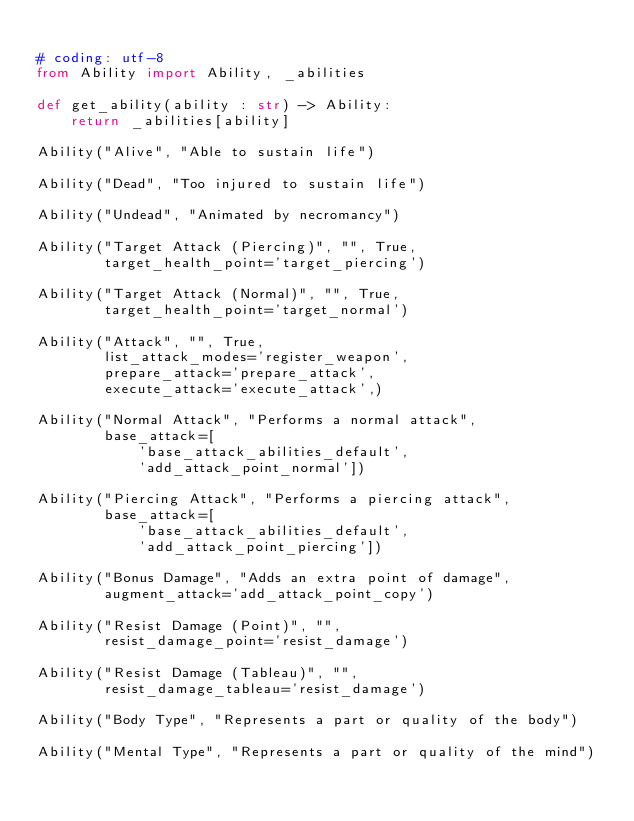<code> <loc_0><loc_0><loc_500><loc_500><_Python_>
# coding: utf-8
from Ability import Ability, _abilities

def get_ability(ability : str) -> Ability:
    return _abilities[ability]

Ability("Alive", "Able to sustain life")

Ability("Dead", "Too injured to sustain life")

Ability("Undead", "Animated by necromancy")

Ability("Target Attack (Piercing)", "", True,
        target_health_point='target_piercing')

Ability("Target Attack (Normal)", "", True,
        target_health_point='target_normal')

Ability("Attack", "", True,
        list_attack_modes='register_weapon',
        prepare_attack='prepare_attack',
        execute_attack='execute_attack',)

Ability("Normal Attack", "Performs a normal attack",
        base_attack=[
            'base_attack_abilities_default',
            'add_attack_point_normal'])

Ability("Piercing Attack", "Performs a piercing attack",
        base_attack=[
            'base_attack_abilities_default',
            'add_attack_point_piercing'])

Ability("Bonus Damage", "Adds an extra point of damage",
        augment_attack='add_attack_point_copy')

Ability("Resist Damage (Point)", "",
        resist_damage_point='resist_damage')

Ability("Resist Damage (Tableau)", "",
        resist_damage_tableau='resist_damage')

Ability("Body Type", "Represents a part or quality of the body")

Ability("Mental Type", "Represents a part or quality of the mind")
</code> 